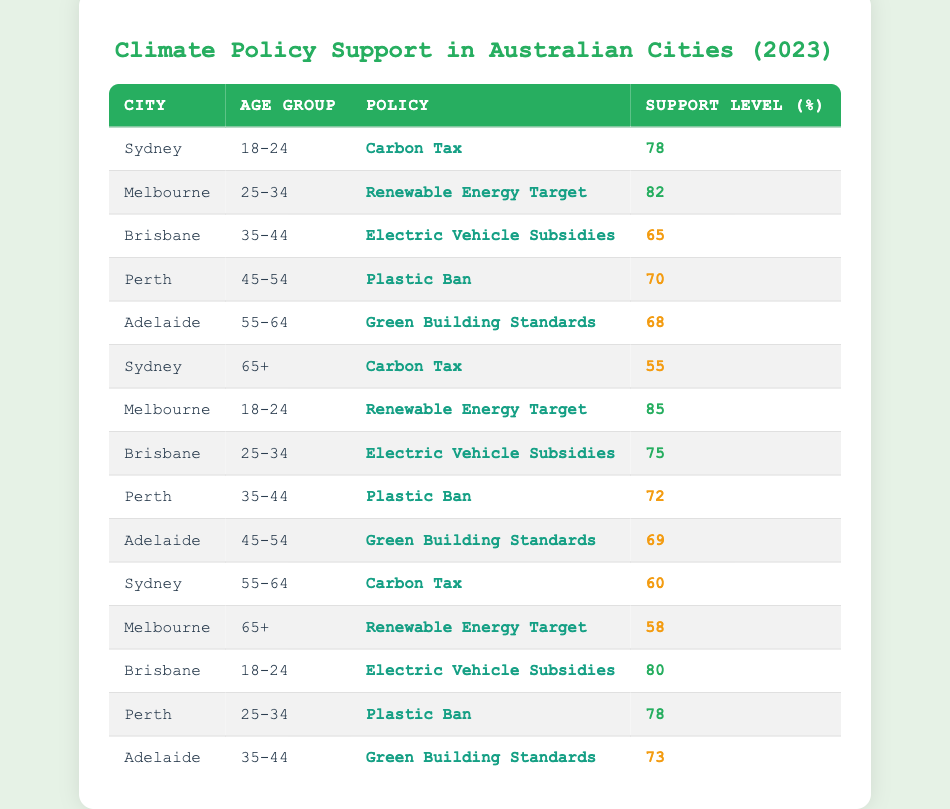What is the support level for the Carbon Tax among 18-24 year-olds in Sydney? According to the table, the support level for the Carbon Tax among 18-24 year-olds in Sydney is specifically listed as 78.
Answer: 78 Which age group in Melbourne shows the highest support for a Renewable Energy Target? By analyzing the table, the 18-24 age group in Melbourne has a support level of 85 for the Renewable Energy Target, which is higher compared to the 25-34 age group at 82.
Answer: 18-24 What is the average support level for Electric Vehicle Subsidies across all age groups in Brisbane? The support levels for Electric Vehicle Subsidies in Brisbane are 65 (35-44), 75 (25-34), and 80 (18-24). Summing these gives 65 + 75 + 80 = 220, and dividing by 3 produces an average of 220/3 = approximately 73.33.
Answer: 73.33 Is the support level for the Plastic Ban higher in Perth compared to the support level for Green Building Standards in Adelaide? The support level for the Plastic Ban in Perth is 70 (45-54) and 78 (25-34) which is higher than Green Building Standards in Adelaide at 68 (55-64) and 73 (35-44). Therefore, it is true that the support for the Plastic Ban is higher.
Answer: Yes Which city has the lowest support level for climate policies among older adults (65+)? The table shows that in Sydney, the support level for the Carbon Tax is 55 for the 65+ age group, and in Melbourne, it is 58 for the Renewable Energy Target. Hence, Sydney has the lowest support level for climate policies among older adults at 65+.
Answer: Sydney What is the difference in support level for the Carbon Tax between the 18-24 age group and the 65+ age group in Sydney? The support level for the Carbon Tax among the 18-24 age group in Sydney is 78, while for the 65+ age group, it is 55. The difference is calculated as 78 - 55 = 23.
Answer: 23 Which age group in Brisbane has a support level of 80 or higher for any climate policy? The 18-24 age group in Brisbane supports the Electric Vehicle Subsidies with a level of 80, which is the only age group that meets or exceeds 80.
Answer: 18-24 Is the support level for the Renewable Energy Target in Melbourne higher than that in Adelaide? In Melbourne, the support level for the Renewable Energy Target among the 18-24 age group is 85, and in Adelaide, it is 73 among the 35-44 age group for Green Building Standards. Therefore, the statement is true as Melbourne's support is higher.
Answer: Yes 